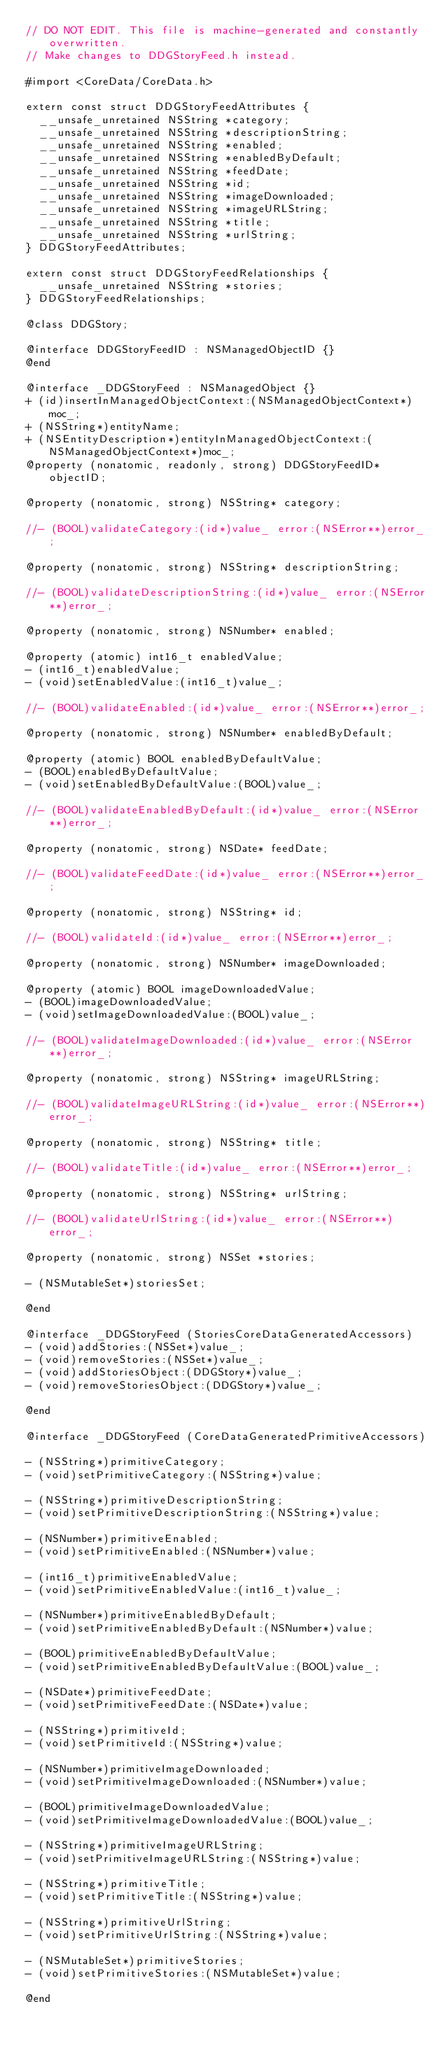<code> <loc_0><loc_0><loc_500><loc_500><_C_>// DO NOT EDIT. This file is machine-generated and constantly overwritten.
// Make changes to DDGStoryFeed.h instead.

#import <CoreData/CoreData.h>

extern const struct DDGStoryFeedAttributes {
	__unsafe_unretained NSString *category;
	__unsafe_unretained NSString *descriptionString;
	__unsafe_unretained NSString *enabled;
	__unsafe_unretained NSString *enabledByDefault;
	__unsafe_unretained NSString *feedDate;
	__unsafe_unretained NSString *id;
	__unsafe_unretained NSString *imageDownloaded;
	__unsafe_unretained NSString *imageURLString;
	__unsafe_unretained NSString *title;
	__unsafe_unretained NSString *urlString;
} DDGStoryFeedAttributes;

extern const struct DDGStoryFeedRelationships {
	__unsafe_unretained NSString *stories;
} DDGStoryFeedRelationships;

@class DDGStory;

@interface DDGStoryFeedID : NSManagedObjectID {}
@end

@interface _DDGStoryFeed : NSManagedObject {}
+ (id)insertInManagedObjectContext:(NSManagedObjectContext*)moc_;
+ (NSString*)entityName;
+ (NSEntityDescription*)entityInManagedObjectContext:(NSManagedObjectContext*)moc_;
@property (nonatomic, readonly, strong) DDGStoryFeedID* objectID;

@property (nonatomic, strong) NSString* category;

//- (BOOL)validateCategory:(id*)value_ error:(NSError**)error_;

@property (nonatomic, strong) NSString* descriptionString;

//- (BOOL)validateDescriptionString:(id*)value_ error:(NSError**)error_;

@property (nonatomic, strong) NSNumber* enabled;

@property (atomic) int16_t enabledValue;
- (int16_t)enabledValue;
- (void)setEnabledValue:(int16_t)value_;

//- (BOOL)validateEnabled:(id*)value_ error:(NSError**)error_;

@property (nonatomic, strong) NSNumber* enabledByDefault;

@property (atomic) BOOL enabledByDefaultValue;
- (BOOL)enabledByDefaultValue;
- (void)setEnabledByDefaultValue:(BOOL)value_;

//- (BOOL)validateEnabledByDefault:(id*)value_ error:(NSError**)error_;

@property (nonatomic, strong) NSDate* feedDate;

//- (BOOL)validateFeedDate:(id*)value_ error:(NSError**)error_;

@property (nonatomic, strong) NSString* id;

//- (BOOL)validateId:(id*)value_ error:(NSError**)error_;

@property (nonatomic, strong) NSNumber* imageDownloaded;

@property (atomic) BOOL imageDownloadedValue;
- (BOOL)imageDownloadedValue;
- (void)setImageDownloadedValue:(BOOL)value_;

//- (BOOL)validateImageDownloaded:(id*)value_ error:(NSError**)error_;

@property (nonatomic, strong) NSString* imageURLString;

//- (BOOL)validateImageURLString:(id*)value_ error:(NSError**)error_;

@property (nonatomic, strong) NSString* title;

//- (BOOL)validateTitle:(id*)value_ error:(NSError**)error_;

@property (nonatomic, strong) NSString* urlString;

//- (BOOL)validateUrlString:(id*)value_ error:(NSError**)error_;

@property (nonatomic, strong) NSSet *stories;

- (NSMutableSet*)storiesSet;

@end

@interface _DDGStoryFeed (StoriesCoreDataGeneratedAccessors)
- (void)addStories:(NSSet*)value_;
- (void)removeStories:(NSSet*)value_;
- (void)addStoriesObject:(DDGStory*)value_;
- (void)removeStoriesObject:(DDGStory*)value_;

@end

@interface _DDGStoryFeed (CoreDataGeneratedPrimitiveAccessors)

- (NSString*)primitiveCategory;
- (void)setPrimitiveCategory:(NSString*)value;

- (NSString*)primitiveDescriptionString;
- (void)setPrimitiveDescriptionString:(NSString*)value;

- (NSNumber*)primitiveEnabled;
- (void)setPrimitiveEnabled:(NSNumber*)value;

- (int16_t)primitiveEnabledValue;
- (void)setPrimitiveEnabledValue:(int16_t)value_;

- (NSNumber*)primitiveEnabledByDefault;
- (void)setPrimitiveEnabledByDefault:(NSNumber*)value;

- (BOOL)primitiveEnabledByDefaultValue;
- (void)setPrimitiveEnabledByDefaultValue:(BOOL)value_;

- (NSDate*)primitiveFeedDate;
- (void)setPrimitiveFeedDate:(NSDate*)value;

- (NSString*)primitiveId;
- (void)setPrimitiveId:(NSString*)value;

- (NSNumber*)primitiveImageDownloaded;
- (void)setPrimitiveImageDownloaded:(NSNumber*)value;

- (BOOL)primitiveImageDownloadedValue;
- (void)setPrimitiveImageDownloadedValue:(BOOL)value_;

- (NSString*)primitiveImageURLString;
- (void)setPrimitiveImageURLString:(NSString*)value;

- (NSString*)primitiveTitle;
- (void)setPrimitiveTitle:(NSString*)value;

- (NSString*)primitiveUrlString;
- (void)setPrimitiveUrlString:(NSString*)value;

- (NSMutableSet*)primitiveStories;
- (void)setPrimitiveStories:(NSMutableSet*)value;

@end
</code> 